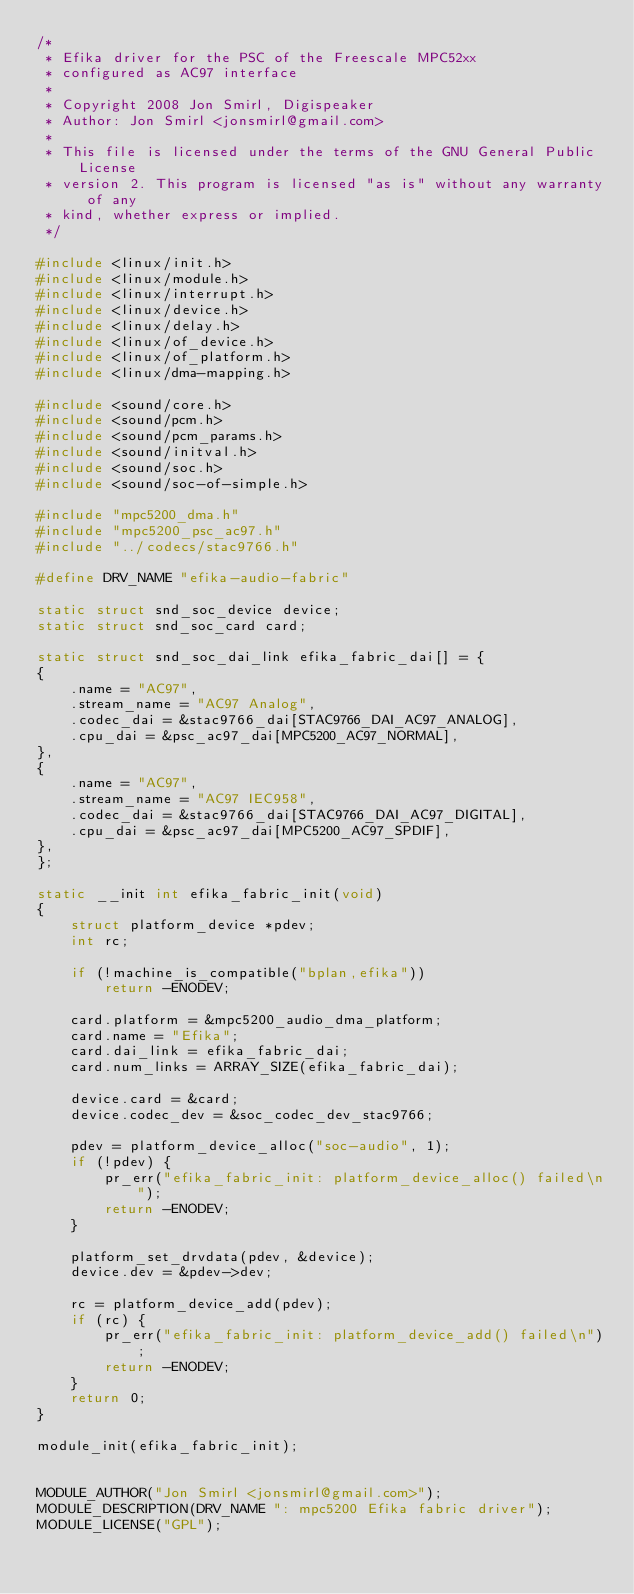Convert code to text. <code><loc_0><loc_0><loc_500><loc_500><_C_>/*
 * Efika driver for the PSC of the Freescale MPC52xx
 * configured as AC97 interface
 *
 * Copyright 2008 Jon Smirl, Digispeaker
 * Author: Jon Smirl <jonsmirl@gmail.com>
 *
 * This file is licensed under the terms of the GNU General Public License
 * version 2. This program is licensed "as is" without any warranty of any
 * kind, whether express or implied.
 */

#include <linux/init.h>
#include <linux/module.h>
#include <linux/interrupt.h>
#include <linux/device.h>
#include <linux/delay.h>
#include <linux/of_device.h>
#include <linux/of_platform.h>
#include <linux/dma-mapping.h>

#include <sound/core.h>
#include <sound/pcm.h>
#include <sound/pcm_params.h>
#include <sound/initval.h>
#include <sound/soc.h>
#include <sound/soc-of-simple.h>

#include "mpc5200_dma.h"
#include "mpc5200_psc_ac97.h"
#include "../codecs/stac9766.h"

#define DRV_NAME "efika-audio-fabric"

static struct snd_soc_device device;
static struct snd_soc_card card;

static struct snd_soc_dai_link efika_fabric_dai[] = {
{
	.name = "AC97",
	.stream_name = "AC97 Analog",
	.codec_dai = &stac9766_dai[STAC9766_DAI_AC97_ANALOG],
	.cpu_dai = &psc_ac97_dai[MPC5200_AC97_NORMAL],
},
{
	.name = "AC97",
	.stream_name = "AC97 IEC958",
	.codec_dai = &stac9766_dai[STAC9766_DAI_AC97_DIGITAL],
	.cpu_dai = &psc_ac97_dai[MPC5200_AC97_SPDIF],
},
};

static __init int efika_fabric_init(void)
{
	struct platform_device *pdev;
	int rc;

	if (!machine_is_compatible("bplan,efika"))
		return -ENODEV;

	card.platform = &mpc5200_audio_dma_platform;
	card.name = "Efika";
	card.dai_link = efika_fabric_dai;
	card.num_links = ARRAY_SIZE(efika_fabric_dai);

	device.card = &card;
	device.codec_dev = &soc_codec_dev_stac9766;

	pdev = platform_device_alloc("soc-audio", 1);
	if (!pdev) {
		pr_err("efika_fabric_init: platform_device_alloc() failed\n");
		return -ENODEV;
	}

	platform_set_drvdata(pdev, &device);
	device.dev = &pdev->dev;

	rc = platform_device_add(pdev);
	if (rc) {
		pr_err("efika_fabric_init: platform_device_add() failed\n");
		return -ENODEV;
	}
	return 0;
}

module_init(efika_fabric_init);


MODULE_AUTHOR("Jon Smirl <jonsmirl@gmail.com>");
MODULE_DESCRIPTION(DRV_NAME ": mpc5200 Efika fabric driver");
MODULE_LICENSE("GPL");

</code> 